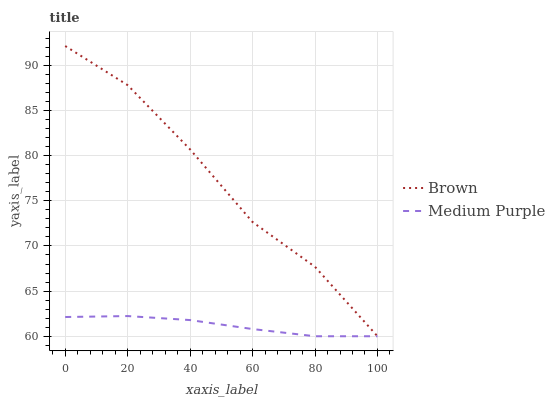Does Brown have the minimum area under the curve?
Answer yes or no. No. Is Brown the smoothest?
Answer yes or no. No. 